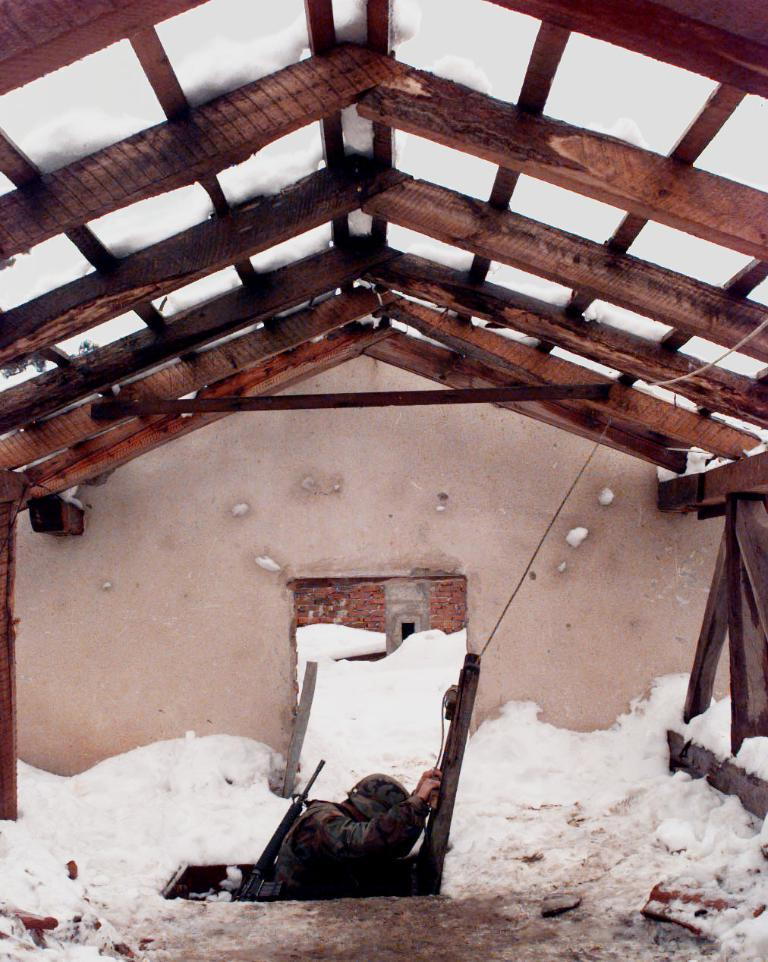Who or what is present in the image? There is a person in the image. What is the ground covered with in the image? There is snow on the ground in the image. What can be seen in the background of the image? There is a wall and a roof in the background of the image. What type of arithmetic problem is the person solving in the image? There is no arithmetic problem visible in the image, as it only shows a person in the snow with a wall and roof in the background. 